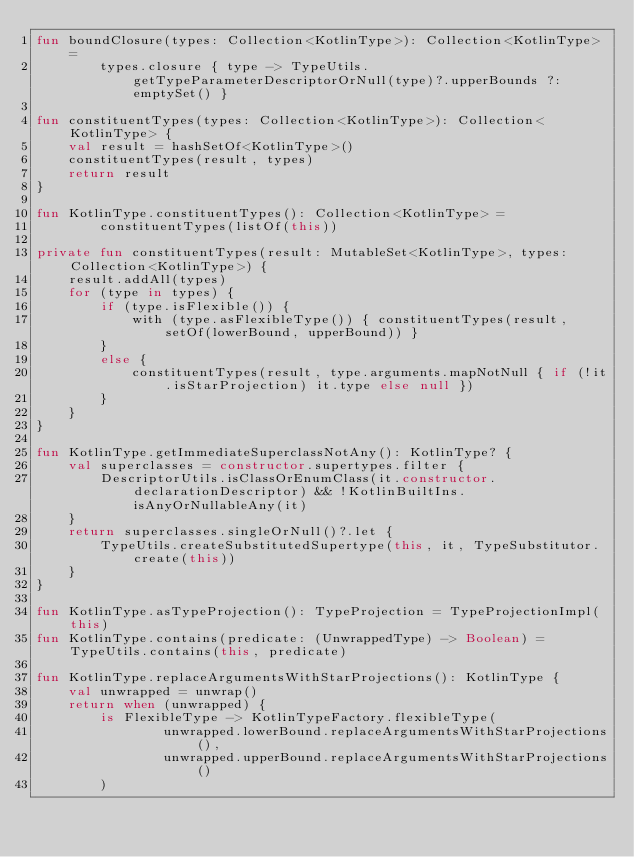Convert code to text. <code><loc_0><loc_0><loc_500><loc_500><_Kotlin_>fun boundClosure(types: Collection<KotlinType>): Collection<KotlinType> =
        types.closure { type -> TypeUtils.getTypeParameterDescriptorOrNull(type)?.upperBounds ?: emptySet() }

fun constituentTypes(types: Collection<KotlinType>): Collection<KotlinType> {
    val result = hashSetOf<KotlinType>()
    constituentTypes(result, types)
    return result
}

fun KotlinType.constituentTypes(): Collection<KotlinType> =
        constituentTypes(listOf(this))

private fun constituentTypes(result: MutableSet<KotlinType>, types: Collection<KotlinType>) {
    result.addAll(types)
    for (type in types) {
        if (type.isFlexible()) {
            with (type.asFlexibleType()) { constituentTypes(result, setOf(lowerBound, upperBound)) }
        }
        else {
            constituentTypes(result, type.arguments.mapNotNull { if (!it.isStarProjection) it.type else null })
        }
    }
}

fun KotlinType.getImmediateSuperclassNotAny(): KotlinType? {
    val superclasses = constructor.supertypes.filter {
        DescriptorUtils.isClassOrEnumClass(it.constructor.declarationDescriptor) && !KotlinBuiltIns.isAnyOrNullableAny(it)
    }
    return superclasses.singleOrNull()?.let {
        TypeUtils.createSubstitutedSupertype(this, it, TypeSubstitutor.create(this))
    }
}

fun KotlinType.asTypeProjection(): TypeProjection = TypeProjectionImpl(this)
fun KotlinType.contains(predicate: (UnwrappedType) -> Boolean) = TypeUtils.contains(this, predicate)

fun KotlinType.replaceArgumentsWithStarProjections(): KotlinType {
    val unwrapped = unwrap()
    return when (unwrapped) {
        is FlexibleType -> KotlinTypeFactory.flexibleType(
                unwrapped.lowerBound.replaceArgumentsWithStarProjections(),
                unwrapped.upperBound.replaceArgumentsWithStarProjections()
        )</code> 